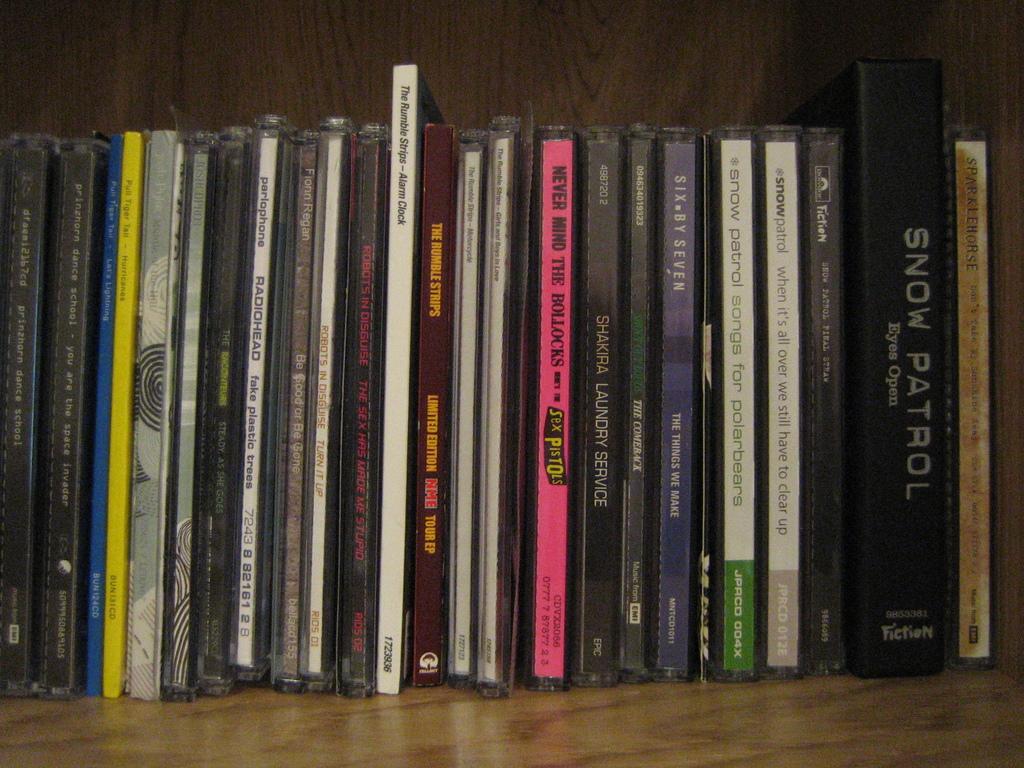What is the album name for the sex pistols?
Ensure brevity in your answer.  Never mind the bollocks. What kind of patrol?
Provide a succinct answer. Snow. 